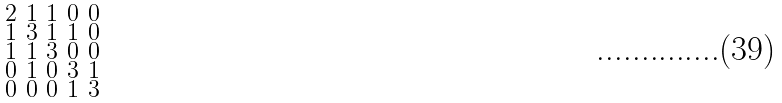Convert formula to latex. <formula><loc_0><loc_0><loc_500><loc_500>\begin{smallmatrix} 2 & 1 & 1 & 0 & 0 \\ 1 & 3 & 1 & 1 & 0 \\ 1 & 1 & 3 & 0 & 0 \\ 0 & 1 & 0 & 3 & 1 \\ 0 & 0 & 0 & 1 & 3 \end{smallmatrix}</formula> 